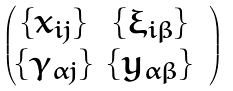<formula> <loc_0><loc_0><loc_500><loc_500>\begin{pmatrix} \{ x _ { i j } \} & \{ \xi _ { i \beta } \} \\ \{ \gamma _ { \alpha j } \} & \{ y _ { \alpha \beta } \} & \end{pmatrix}</formula> 